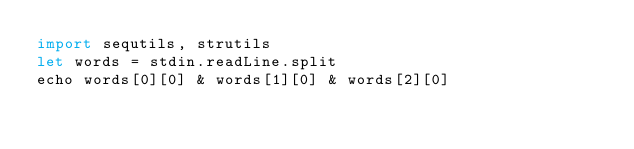Convert code to text. <code><loc_0><loc_0><loc_500><loc_500><_Nim_>import sequtils, strutils
let words = stdin.readLine.split
echo words[0][0] & words[1][0] & words[2][0]</code> 